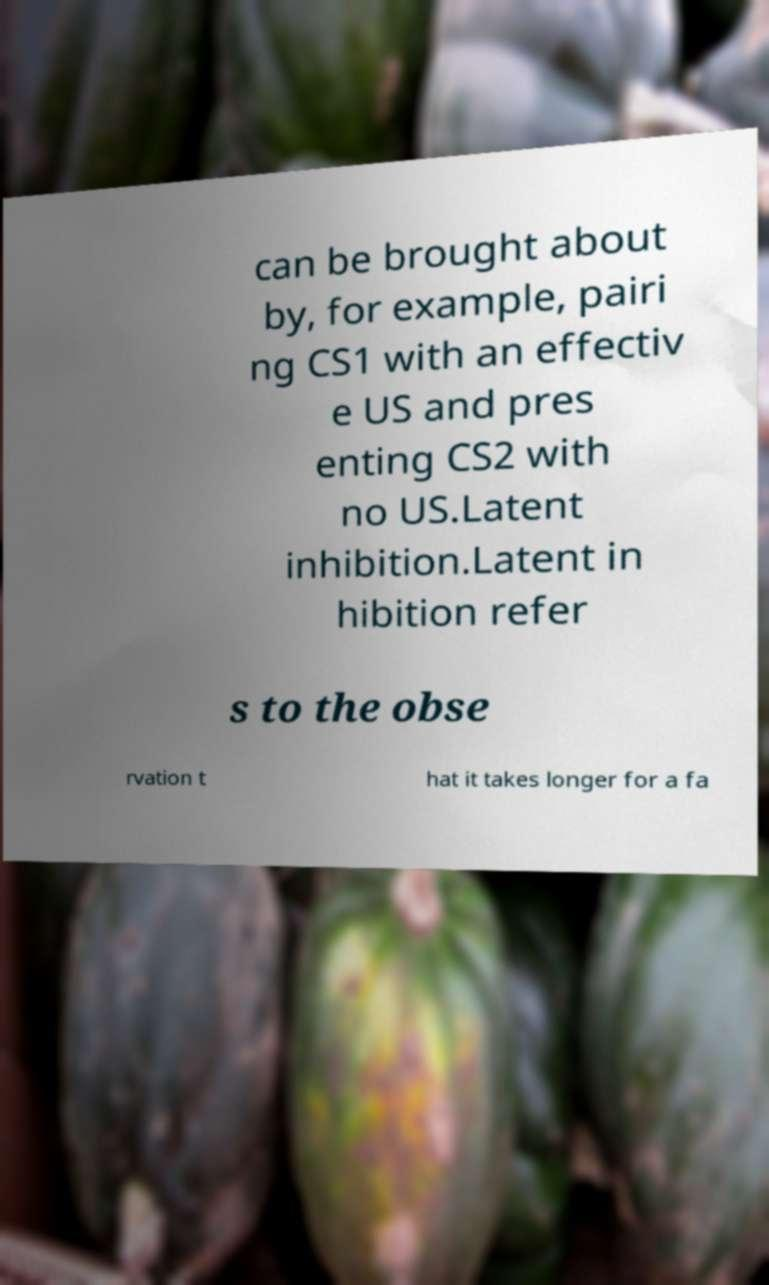Please identify and transcribe the text found in this image. can be brought about by, for example, pairi ng CS1 with an effectiv e US and pres enting CS2 with no US.Latent inhibition.Latent in hibition refer s to the obse rvation t hat it takes longer for a fa 